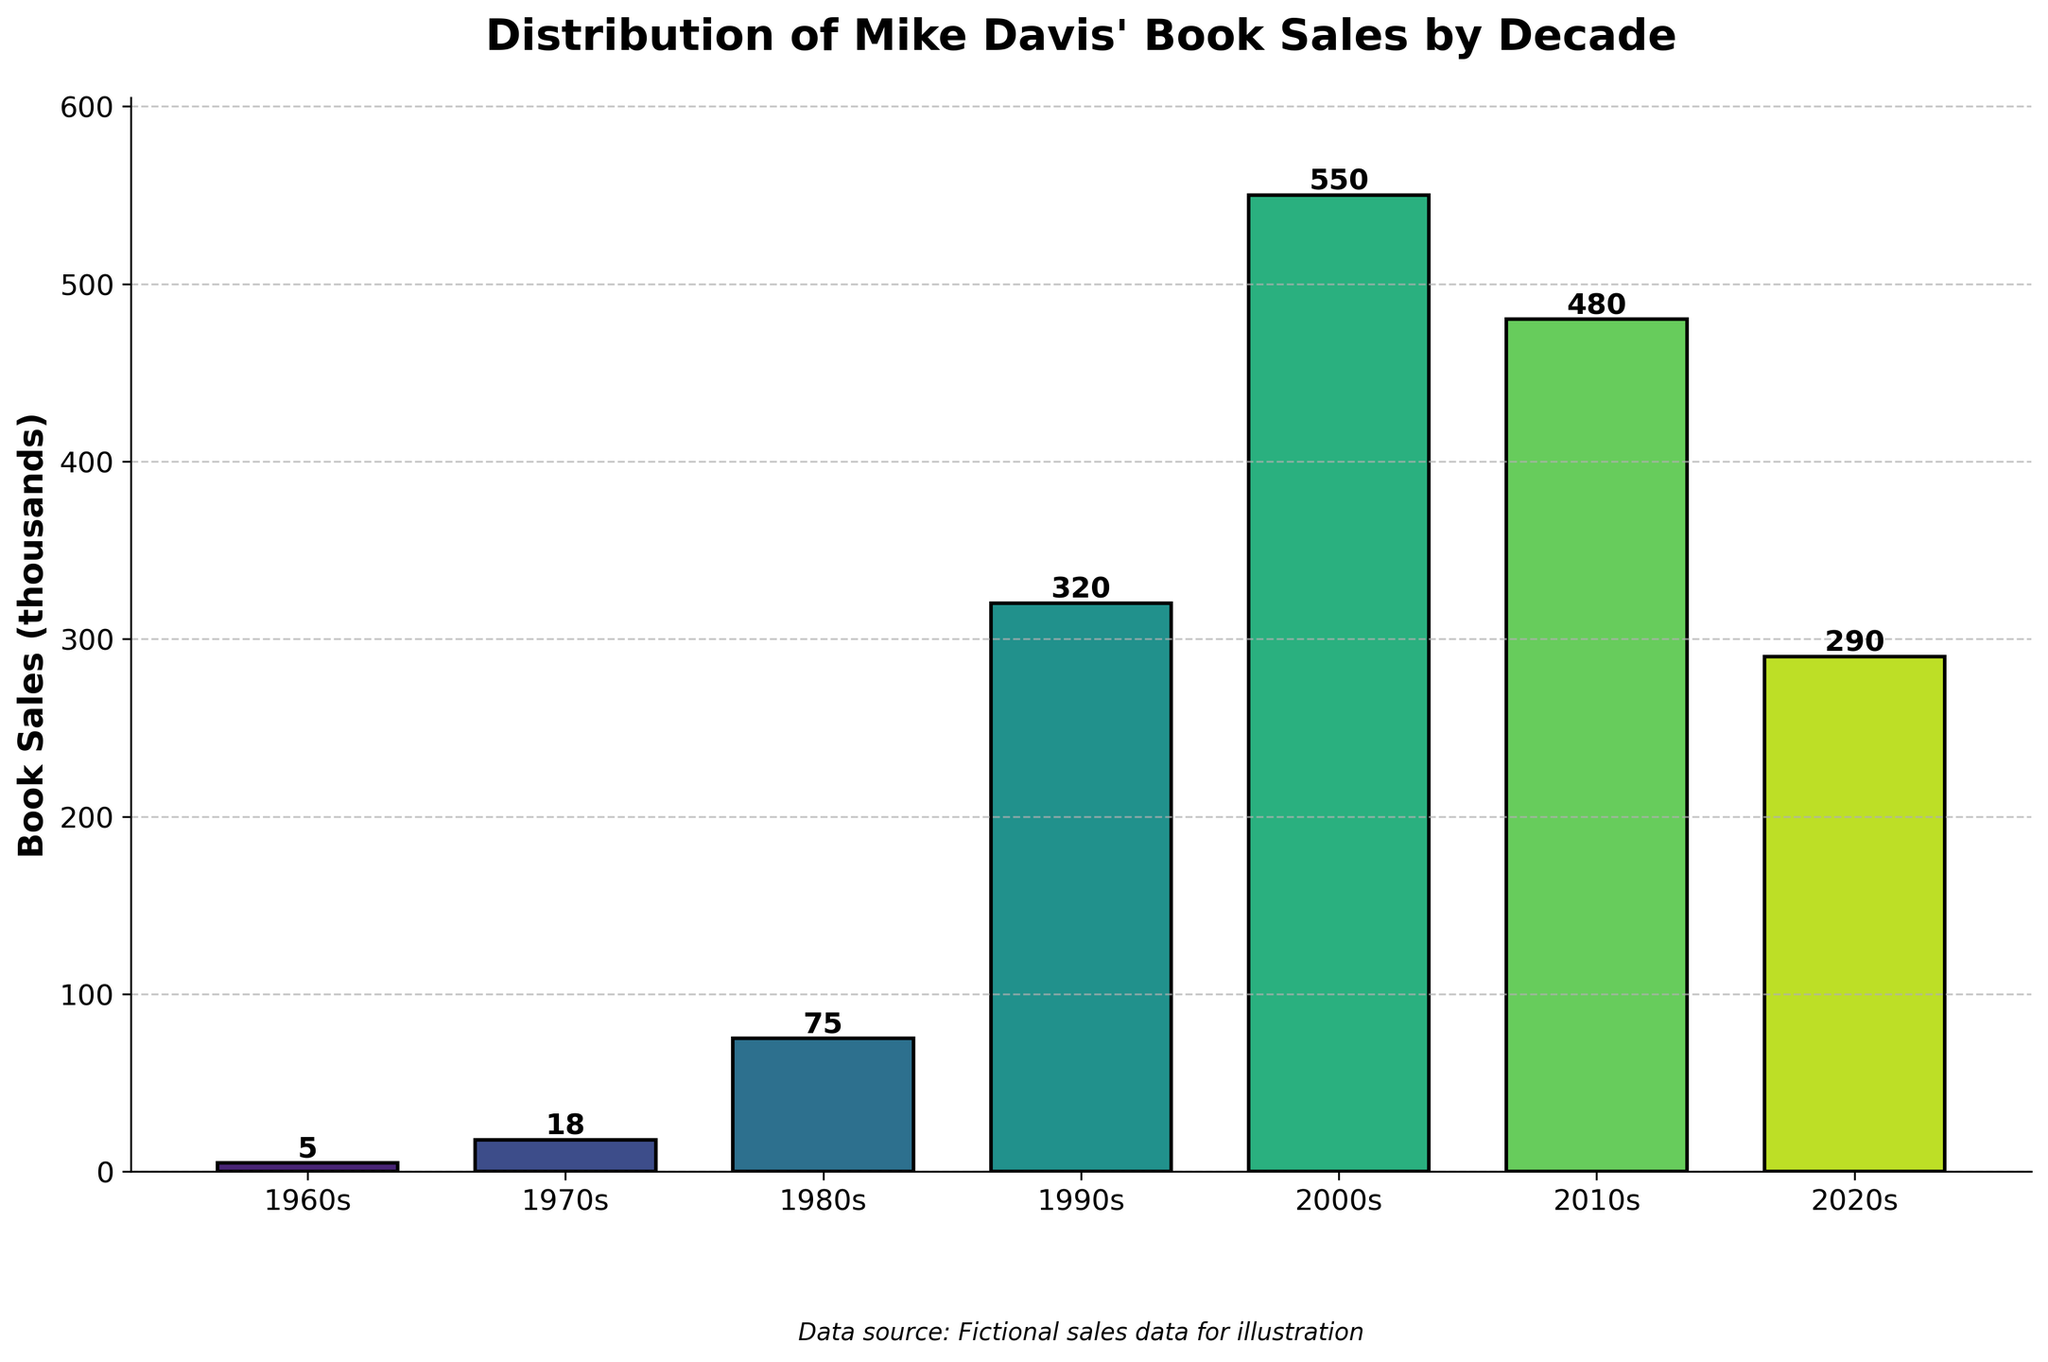What decade had the highest book sales? Look at the bar chart and identify which bar is the tallest. The tallest bar corresponds to the 2000s.
Answer: 2000s Which two decades had the closest book sales? Compare the heights of the bars. The 2010s and the 2020s have sales of 480,000 and 290,000 respectively, which are closer to each other than other pairs.
Answer: 2010s and 2020s What is the total book sales from the 1990s to 2020s? Add the book sales from the 1990s, 2000s, 2010s, and 2020s: 320,000 + 550,000 + 480,000 + 290,000.
Answer: 1,640,000 Which decade saw the largest increase in book sales compared to the previous decade? Calculate the increase for each decade: 
- 1960s to 1970s: 18,000 - 5,000 = 13,000
- 1970s to 1980s: 75,000 - 18,000 = 57,000
- 1980s to 1990s: 320,000 - 75,000 = 245,000
- 1990s to 2000s: 550,000 - 320,000 = 230,000
- 2000s to 2010s: 480,000 - 550,000 = -70,000
- 2010s to 2020s: 290,000 - 480,000 = -190,000
The largest increase is from the 1980s to the 1990s.
Answer: 1980s to 1990s What is the median of the book sales figures? List the book sales values in numerical order: 5,000; 18,000; 75,000; 290,000; 320,000; 480,000; 550,000. The median is the middle value, which is 290,000.
Answer: 290,000 Which decade has almost half the sales of the most successful decade? The most successful decade is the 2000s with 550,000 sales. Half of this is 275,000. The closest decade to 275,000 is the 2020s with 290,000 sales.
Answer: 2020s By how much did the book sales change from the 2010s to the 2020s? Subtract the 2020s book sales from the 2010s book sales: 480,000 - 290,000.
Answer: 190,000 Which bars’ heights are closest in magnitude visually? Compare the heights visually and find that the bars for the 1990s and 2020s are the closest in magnitude visually.
Answer: 1990s and 2020s What percentage of the total sales were made in the 2000s? Calculate the total book sales: 5,000 + 18,000 + 75,000 + 320,000 + 550,000 + 480,000 + 290,000 = 1,738,000. Next, calculate the percentage of 550,000 out of 1,738,000: (550,000/1,738,000) * 100%.
Answer: 31.65% Do more recent decades generally have higher sales compared to earlier decades? Observe the trend in the bar chart. There is a general increase in sales from the 1960s to the 2000s, peaking, and then a slight decline in the 2010s and 2020s.
Answer: Yes 